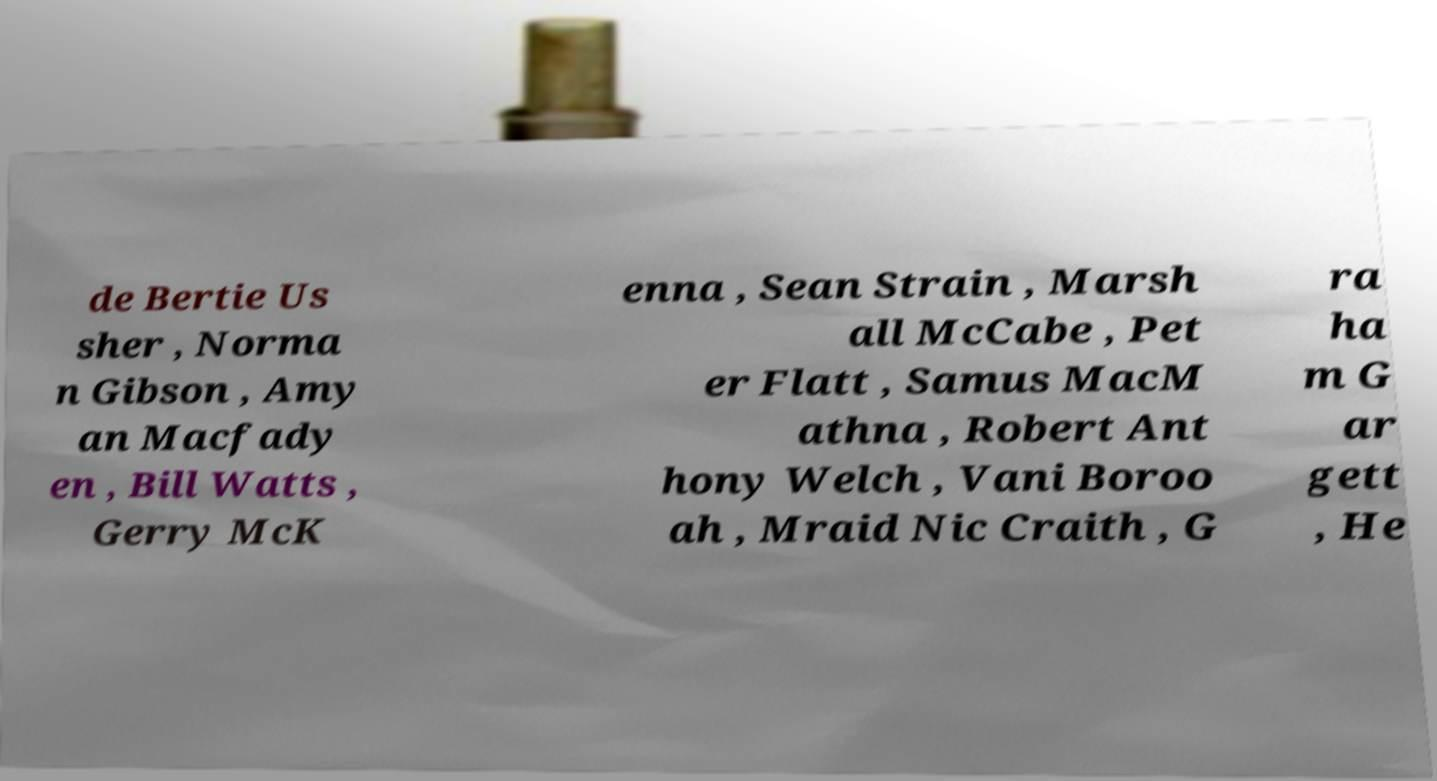Could you extract and type out the text from this image? de Bertie Us sher , Norma n Gibson , Amy an Macfady en , Bill Watts , Gerry McK enna , Sean Strain , Marsh all McCabe , Pet er Flatt , Samus MacM athna , Robert Ant hony Welch , Vani Boroo ah , Mraid Nic Craith , G ra ha m G ar gett , He 